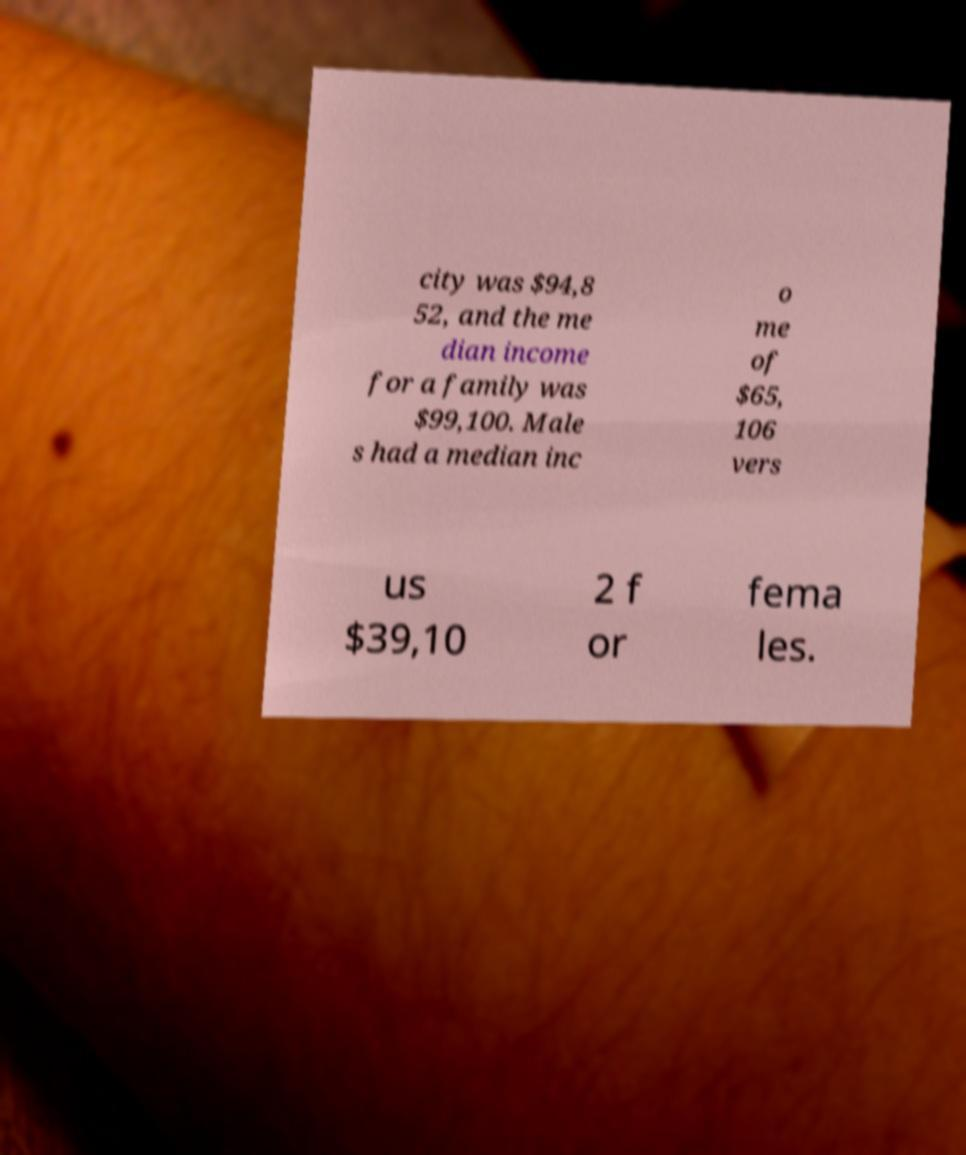Could you extract and type out the text from this image? city was $94,8 52, and the me dian income for a family was $99,100. Male s had a median inc o me of $65, 106 vers us $39,10 2 f or fema les. 